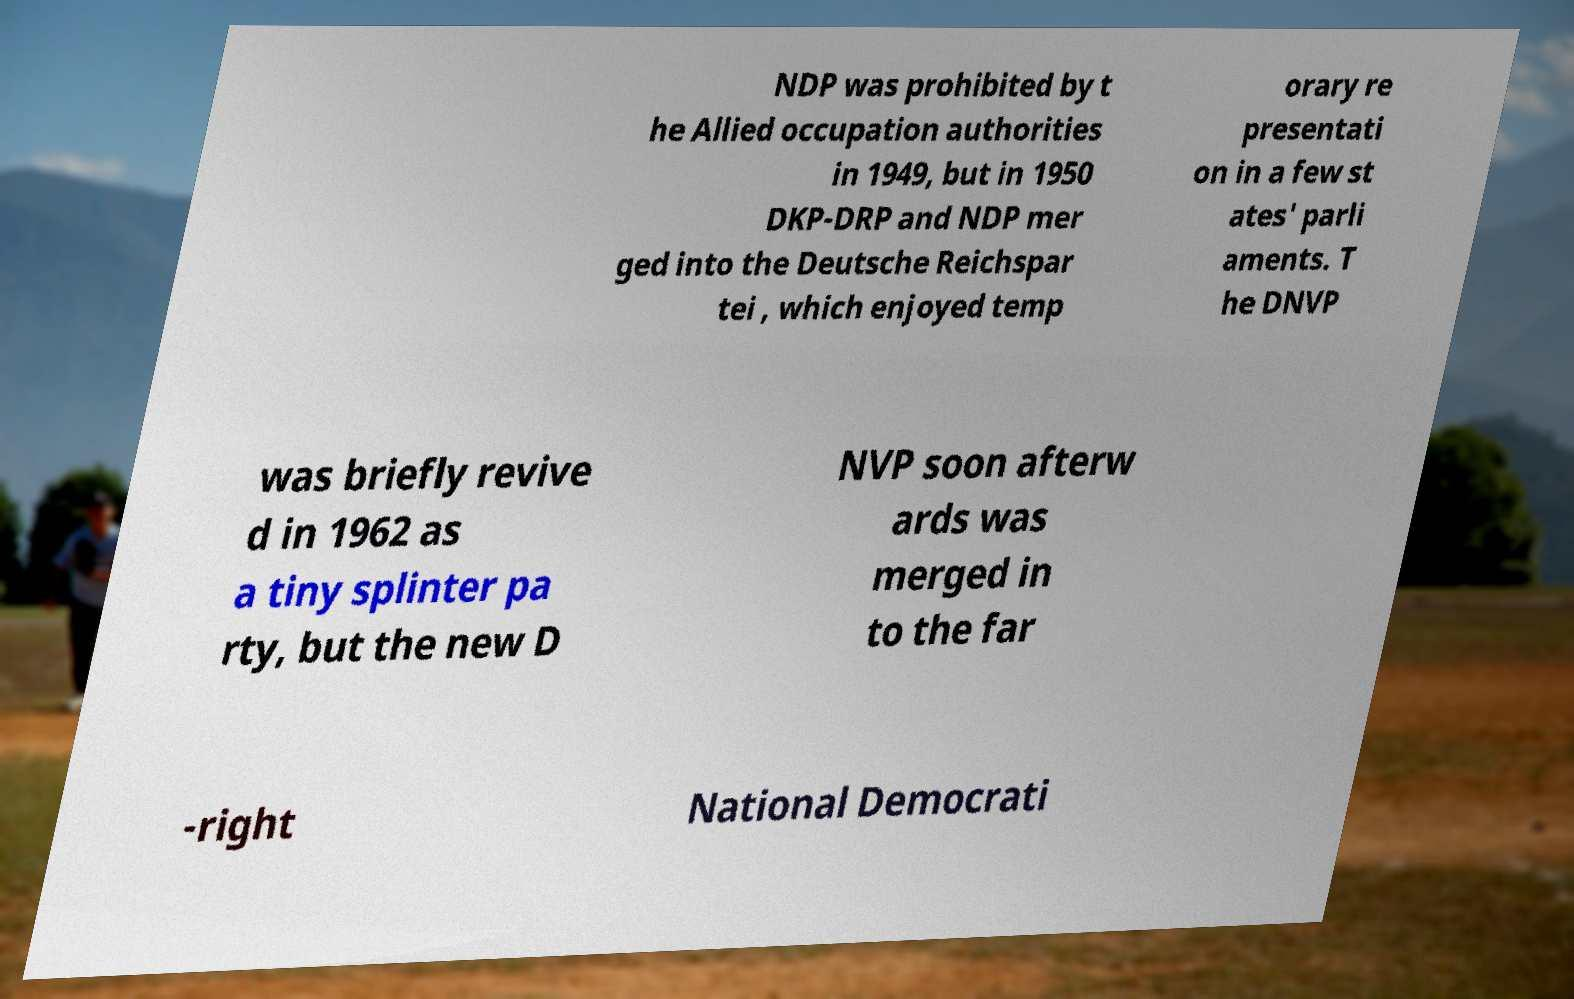Please identify and transcribe the text found in this image. NDP was prohibited by t he Allied occupation authorities in 1949, but in 1950 DKP-DRP and NDP mer ged into the Deutsche Reichspar tei , which enjoyed temp orary re presentati on in a few st ates' parli aments. T he DNVP was briefly revive d in 1962 as a tiny splinter pa rty, but the new D NVP soon afterw ards was merged in to the far -right National Democrati 